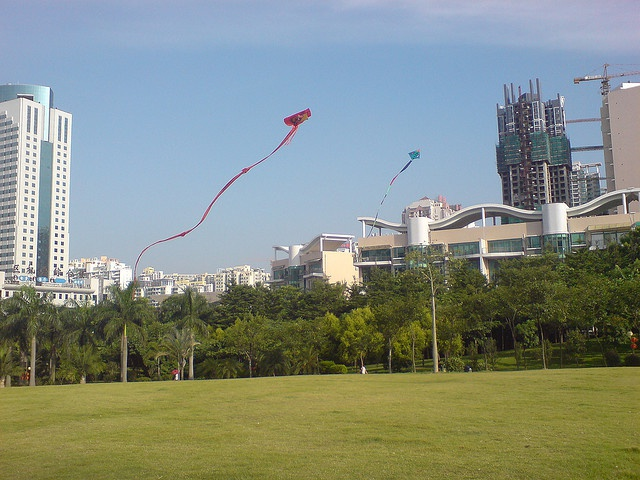Describe the objects in this image and their specific colors. I can see kite in darkgray, brown, violet, and purple tones, kite in darkgray, lightblue, gray, and teal tones, people in darkgray, olive, beige, and black tones, people in darkgray, black, brown, and maroon tones, and people in darkgray, black, gray, and tan tones in this image. 